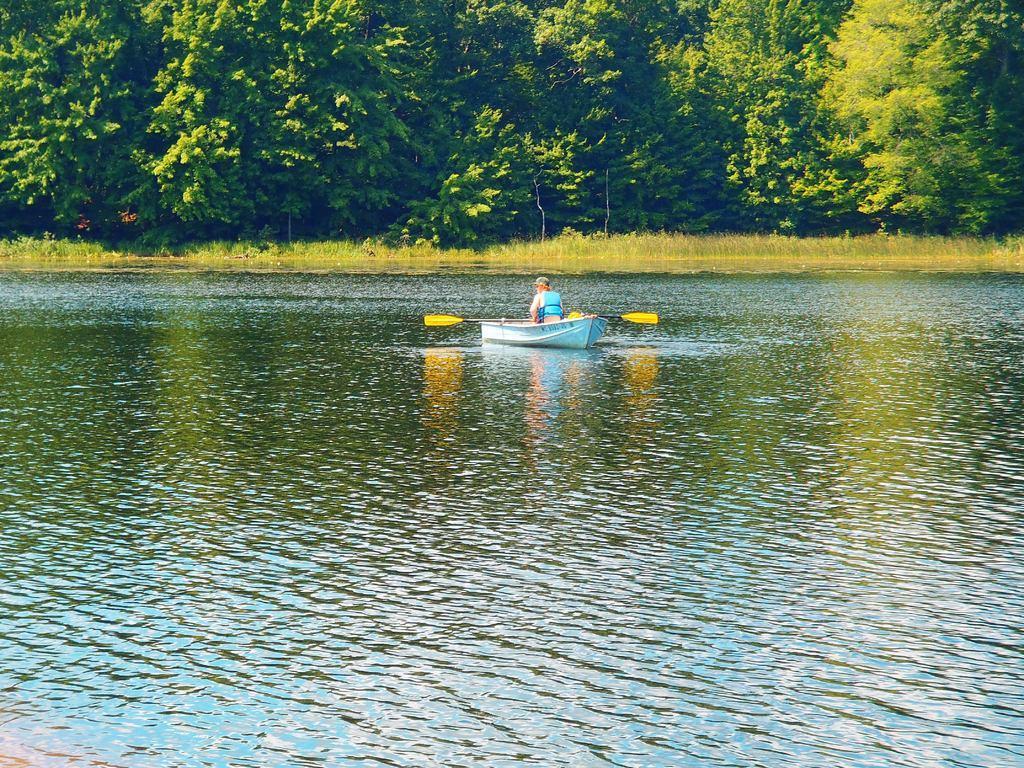Could you give a brief overview of what you see in this image? In the center of the image, we can see a person on the boat and in the background, there are trees. At the bottom, there is water. 